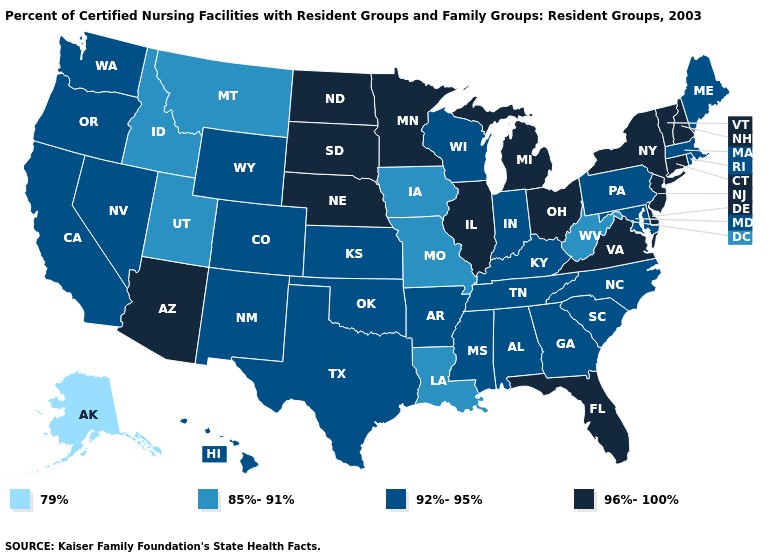Name the states that have a value in the range 92%-95%?
Be succinct. Alabama, Arkansas, California, Colorado, Georgia, Hawaii, Indiana, Kansas, Kentucky, Maine, Maryland, Massachusetts, Mississippi, Nevada, New Mexico, North Carolina, Oklahoma, Oregon, Pennsylvania, Rhode Island, South Carolina, Tennessee, Texas, Washington, Wisconsin, Wyoming. Name the states that have a value in the range 96%-100%?
Concise answer only. Arizona, Connecticut, Delaware, Florida, Illinois, Michigan, Minnesota, Nebraska, New Hampshire, New Jersey, New York, North Dakota, Ohio, South Dakota, Vermont, Virginia. Among the states that border Iowa , which have the lowest value?
Concise answer only. Missouri. Does Kansas have the same value as Connecticut?
Be succinct. No. What is the lowest value in the West?
Concise answer only. 79%. Does the map have missing data?
Short answer required. No. What is the lowest value in the USA?
Concise answer only. 79%. Which states hav the highest value in the MidWest?
Write a very short answer. Illinois, Michigan, Minnesota, Nebraska, North Dakota, Ohio, South Dakota. Does Alaska have the lowest value in the USA?
Write a very short answer. Yes. What is the value of Virginia?
Write a very short answer. 96%-100%. Among the states that border Oklahoma , does New Mexico have the lowest value?
Write a very short answer. No. Does Tennessee have a lower value than Alabama?
Concise answer only. No. What is the value of Idaho?
Write a very short answer. 85%-91%. Which states hav the highest value in the Northeast?
Answer briefly. Connecticut, New Hampshire, New Jersey, New York, Vermont. What is the lowest value in the USA?
Answer briefly. 79%. 